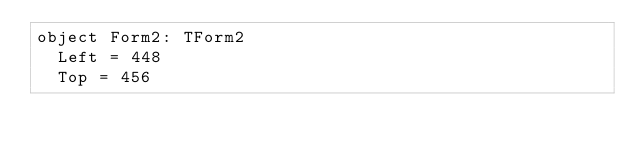<code> <loc_0><loc_0><loc_500><loc_500><_Pascal_>object Form2: TForm2
  Left = 448
  Top = 456</code> 